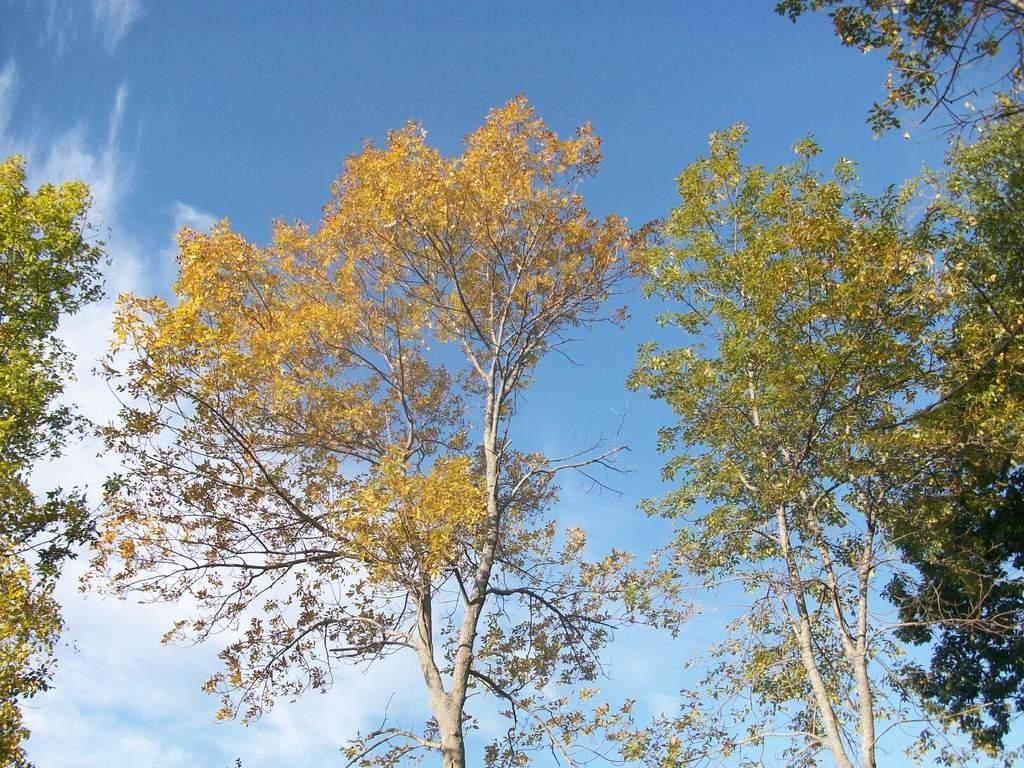What type of vegetation is present in the image? There are trees with branches and leaves in the image. What can be seen in the background of the image? The sky is visible in the background of the image. What type of reaction can be seen from the trees in the image? There is no reaction visible from the trees in the image, as trees do not have the ability to express emotions or reactions. 